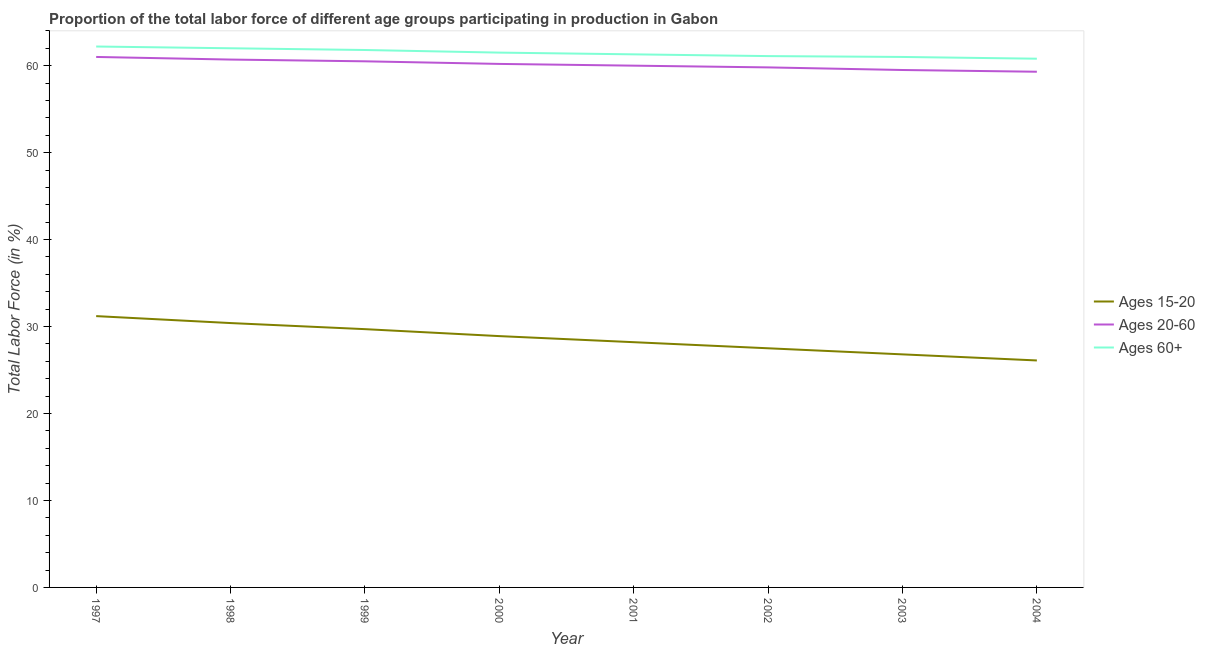Does the line corresponding to percentage of labor force within the age group 20-60 intersect with the line corresponding to percentage of labor force within the age group 15-20?
Make the answer very short. No. What is the percentage of labor force above age 60 in 1998?
Offer a very short reply. 62. Across all years, what is the minimum percentage of labor force within the age group 15-20?
Offer a very short reply. 26.1. In which year was the percentage of labor force within the age group 15-20 maximum?
Your answer should be compact. 1997. What is the total percentage of labor force within the age group 15-20 in the graph?
Your answer should be compact. 228.8. What is the difference between the percentage of labor force within the age group 15-20 in 1997 and that in 2001?
Keep it short and to the point. 3. What is the difference between the percentage of labor force within the age group 20-60 in 2001 and the percentage of labor force above age 60 in 2000?
Offer a terse response. -1.5. What is the average percentage of labor force within the age group 15-20 per year?
Make the answer very short. 28.6. In the year 2000, what is the difference between the percentage of labor force above age 60 and percentage of labor force within the age group 15-20?
Keep it short and to the point. 32.6. In how many years, is the percentage of labor force within the age group 15-20 greater than 4 %?
Keep it short and to the point. 8. What is the ratio of the percentage of labor force within the age group 20-60 in 2002 to that in 2003?
Your response must be concise. 1.01. Is the percentage of labor force within the age group 15-20 in 2000 less than that in 2003?
Offer a terse response. No. Is the difference between the percentage of labor force above age 60 in 1997 and 1999 greater than the difference between the percentage of labor force within the age group 20-60 in 1997 and 1999?
Offer a terse response. No. What is the difference between the highest and the second highest percentage of labor force within the age group 15-20?
Make the answer very short. 0.8. What is the difference between the highest and the lowest percentage of labor force above age 60?
Offer a terse response. 1.4. Is the sum of the percentage of labor force within the age group 20-60 in 2000 and 2002 greater than the maximum percentage of labor force within the age group 15-20 across all years?
Give a very brief answer. Yes. Is the percentage of labor force within the age group 15-20 strictly greater than the percentage of labor force above age 60 over the years?
Provide a succinct answer. No. Is the percentage of labor force above age 60 strictly less than the percentage of labor force within the age group 15-20 over the years?
Keep it short and to the point. No. Where does the legend appear in the graph?
Your response must be concise. Center right. How many legend labels are there?
Offer a very short reply. 3. What is the title of the graph?
Provide a short and direct response. Proportion of the total labor force of different age groups participating in production in Gabon. What is the Total Labor Force (in %) of Ages 15-20 in 1997?
Give a very brief answer. 31.2. What is the Total Labor Force (in %) in Ages 60+ in 1997?
Give a very brief answer. 62.2. What is the Total Labor Force (in %) of Ages 15-20 in 1998?
Your answer should be very brief. 30.4. What is the Total Labor Force (in %) in Ages 20-60 in 1998?
Offer a very short reply. 60.7. What is the Total Labor Force (in %) in Ages 60+ in 1998?
Make the answer very short. 62. What is the Total Labor Force (in %) in Ages 15-20 in 1999?
Ensure brevity in your answer.  29.7. What is the Total Labor Force (in %) in Ages 20-60 in 1999?
Your answer should be compact. 60.5. What is the Total Labor Force (in %) in Ages 60+ in 1999?
Provide a short and direct response. 61.8. What is the Total Labor Force (in %) in Ages 15-20 in 2000?
Provide a succinct answer. 28.9. What is the Total Labor Force (in %) in Ages 20-60 in 2000?
Make the answer very short. 60.2. What is the Total Labor Force (in %) of Ages 60+ in 2000?
Your answer should be compact. 61.5. What is the Total Labor Force (in %) of Ages 15-20 in 2001?
Your response must be concise. 28.2. What is the Total Labor Force (in %) of Ages 20-60 in 2001?
Offer a terse response. 60. What is the Total Labor Force (in %) of Ages 60+ in 2001?
Make the answer very short. 61.3. What is the Total Labor Force (in %) in Ages 15-20 in 2002?
Ensure brevity in your answer.  27.5. What is the Total Labor Force (in %) in Ages 20-60 in 2002?
Your answer should be very brief. 59.8. What is the Total Labor Force (in %) of Ages 60+ in 2002?
Your response must be concise. 61.1. What is the Total Labor Force (in %) of Ages 15-20 in 2003?
Provide a succinct answer. 26.8. What is the Total Labor Force (in %) in Ages 20-60 in 2003?
Ensure brevity in your answer.  59.5. What is the Total Labor Force (in %) in Ages 60+ in 2003?
Your response must be concise. 61. What is the Total Labor Force (in %) of Ages 15-20 in 2004?
Provide a short and direct response. 26.1. What is the Total Labor Force (in %) in Ages 20-60 in 2004?
Make the answer very short. 59.3. What is the Total Labor Force (in %) of Ages 60+ in 2004?
Provide a short and direct response. 60.8. Across all years, what is the maximum Total Labor Force (in %) in Ages 15-20?
Give a very brief answer. 31.2. Across all years, what is the maximum Total Labor Force (in %) of Ages 20-60?
Keep it short and to the point. 61. Across all years, what is the maximum Total Labor Force (in %) in Ages 60+?
Your answer should be very brief. 62.2. Across all years, what is the minimum Total Labor Force (in %) of Ages 15-20?
Provide a short and direct response. 26.1. Across all years, what is the minimum Total Labor Force (in %) in Ages 20-60?
Give a very brief answer. 59.3. Across all years, what is the minimum Total Labor Force (in %) of Ages 60+?
Offer a very short reply. 60.8. What is the total Total Labor Force (in %) in Ages 15-20 in the graph?
Provide a short and direct response. 228.8. What is the total Total Labor Force (in %) of Ages 20-60 in the graph?
Make the answer very short. 481. What is the total Total Labor Force (in %) of Ages 60+ in the graph?
Offer a terse response. 491.7. What is the difference between the Total Labor Force (in %) of Ages 15-20 in 1997 and that in 1998?
Keep it short and to the point. 0.8. What is the difference between the Total Labor Force (in %) in Ages 20-60 in 1997 and that in 1999?
Provide a succinct answer. 0.5. What is the difference between the Total Labor Force (in %) in Ages 15-20 in 1997 and that in 2000?
Provide a succinct answer. 2.3. What is the difference between the Total Labor Force (in %) of Ages 15-20 in 1997 and that in 2001?
Your answer should be compact. 3. What is the difference between the Total Labor Force (in %) of Ages 60+ in 1997 and that in 2001?
Provide a short and direct response. 0.9. What is the difference between the Total Labor Force (in %) of Ages 15-20 in 1997 and that in 2002?
Make the answer very short. 3.7. What is the difference between the Total Labor Force (in %) of Ages 20-60 in 1997 and that in 2002?
Give a very brief answer. 1.2. What is the difference between the Total Labor Force (in %) of Ages 60+ in 1997 and that in 2002?
Make the answer very short. 1.1. What is the difference between the Total Labor Force (in %) in Ages 15-20 in 1997 and that in 2003?
Make the answer very short. 4.4. What is the difference between the Total Labor Force (in %) of Ages 20-60 in 1997 and that in 2003?
Make the answer very short. 1.5. What is the difference between the Total Labor Force (in %) in Ages 60+ in 1997 and that in 2003?
Provide a succinct answer. 1.2. What is the difference between the Total Labor Force (in %) in Ages 15-20 in 1997 and that in 2004?
Your answer should be compact. 5.1. What is the difference between the Total Labor Force (in %) in Ages 15-20 in 1998 and that in 1999?
Keep it short and to the point. 0.7. What is the difference between the Total Labor Force (in %) of Ages 20-60 in 1998 and that in 1999?
Your response must be concise. 0.2. What is the difference between the Total Labor Force (in %) in Ages 60+ in 1998 and that in 1999?
Your response must be concise. 0.2. What is the difference between the Total Labor Force (in %) of Ages 20-60 in 1998 and that in 2000?
Your answer should be very brief. 0.5. What is the difference between the Total Labor Force (in %) of Ages 60+ in 1998 and that in 2000?
Keep it short and to the point. 0.5. What is the difference between the Total Labor Force (in %) of Ages 20-60 in 1998 and that in 2001?
Your response must be concise. 0.7. What is the difference between the Total Labor Force (in %) of Ages 20-60 in 1998 and that in 2002?
Offer a very short reply. 0.9. What is the difference between the Total Labor Force (in %) in Ages 15-20 in 1998 and that in 2003?
Make the answer very short. 3.6. What is the difference between the Total Labor Force (in %) in Ages 20-60 in 1998 and that in 2003?
Ensure brevity in your answer.  1.2. What is the difference between the Total Labor Force (in %) in Ages 60+ in 1998 and that in 2003?
Ensure brevity in your answer.  1. What is the difference between the Total Labor Force (in %) of Ages 15-20 in 1998 and that in 2004?
Offer a very short reply. 4.3. What is the difference between the Total Labor Force (in %) of Ages 60+ in 1998 and that in 2004?
Your answer should be compact. 1.2. What is the difference between the Total Labor Force (in %) of Ages 15-20 in 1999 and that in 2000?
Provide a succinct answer. 0.8. What is the difference between the Total Labor Force (in %) in Ages 60+ in 1999 and that in 2000?
Make the answer very short. 0.3. What is the difference between the Total Labor Force (in %) of Ages 20-60 in 1999 and that in 2001?
Offer a very short reply. 0.5. What is the difference between the Total Labor Force (in %) in Ages 20-60 in 1999 and that in 2002?
Provide a short and direct response. 0.7. What is the difference between the Total Labor Force (in %) of Ages 20-60 in 1999 and that in 2003?
Make the answer very short. 1. What is the difference between the Total Labor Force (in %) in Ages 20-60 in 1999 and that in 2004?
Ensure brevity in your answer.  1.2. What is the difference between the Total Labor Force (in %) of Ages 60+ in 2000 and that in 2001?
Provide a short and direct response. 0.2. What is the difference between the Total Labor Force (in %) of Ages 15-20 in 2000 and that in 2002?
Offer a terse response. 1.4. What is the difference between the Total Labor Force (in %) of Ages 60+ in 2000 and that in 2002?
Your response must be concise. 0.4. What is the difference between the Total Labor Force (in %) of Ages 60+ in 2000 and that in 2003?
Ensure brevity in your answer.  0.5. What is the difference between the Total Labor Force (in %) in Ages 15-20 in 2000 and that in 2004?
Give a very brief answer. 2.8. What is the difference between the Total Labor Force (in %) in Ages 60+ in 2000 and that in 2004?
Give a very brief answer. 0.7. What is the difference between the Total Labor Force (in %) in Ages 60+ in 2001 and that in 2002?
Your answer should be very brief. 0.2. What is the difference between the Total Labor Force (in %) of Ages 15-20 in 2001 and that in 2003?
Make the answer very short. 1.4. What is the difference between the Total Labor Force (in %) of Ages 20-60 in 2001 and that in 2003?
Ensure brevity in your answer.  0.5. What is the difference between the Total Labor Force (in %) in Ages 20-60 in 2001 and that in 2004?
Your answer should be compact. 0.7. What is the difference between the Total Labor Force (in %) in Ages 15-20 in 2002 and that in 2003?
Offer a terse response. 0.7. What is the difference between the Total Labor Force (in %) in Ages 20-60 in 2002 and that in 2003?
Make the answer very short. 0.3. What is the difference between the Total Labor Force (in %) of Ages 15-20 in 2002 and that in 2004?
Ensure brevity in your answer.  1.4. What is the difference between the Total Labor Force (in %) of Ages 20-60 in 2002 and that in 2004?
Offer a terse response. 0.5. What is the difference between the Total Labor Force (in %) of Ages 15-20 in 2003 and that in 2004?
Provide a succinct answer. 0.7. What is the difference between the Total Labor Force (in %) in Ages 60+ in 2003 and that in 2004?
Keep it short and to the point. 0.2. What is the difference between the Total Labor Force (in %) in Ages 15-20 in 1997 and the Total Labor Force (in %) in Ages 20-60 in 1998?
Ensure brevity in your answer.  -29.5. What is the difference between the Total Labor Force (in %) of Ages 15-20 in 1997 and the Total Labor Force (in %) of Ages 60+ in 1998?
Provide a short and direct response. -30.8. What is the difference between the Total Labor Force (in %) in Ages 15-20 in 1997 and the Total Labor Force (in %) in Ages 20-60 in 1999?
Ensure brevity in your answer.  -29.3. What is the difference between the Total Labor Force (in %) of Ages 15-20 in 1997 and the Total Labor Force (in %) of Ages 60+ in 1999?
Provide a short and direct response. -30.6. What is the difference between the Total Labor Force (in %) of Ages 20-60 in 1997 and the Total Labor Force (in %) of Ages 60+ in 1999?
Offer a terse response. -0.8. What is the difference between the Total Labor Force (in %) of Ages 15-20 in 1997 and the Total Labor Force (in %) of Ages 20-60 in 2000?
Your answer should be compact. -29. What is the difference between the Total Labor Force (in %) of Ages 15-20 in 1997 and the Total Labor Force (in %) of Ages 60+ in 2000?
Offer a very short reply. -30.3. What is the difference between the Total Labor Force (in %) in Ages 20-60 in 1997 and the Total Labor Force (in %) in Ages 60+ in 2000?
Provide a short and direct response. -0.5. What is the difference between the Total Labor Force (in %) in Ages 15-20 in 1997 and the Total Labor Force (in %) in Ages 20-60 in 2001?
Your answer should be very brief. -28.8. What is the difference between the Total Labor Force (in %) of Ages 15-20 in 1997 and the Total Labor Force (in %) of Ages 60+ in 2001?
Offer a terse response. -30.1. What is the difference between the Total Labor Force (in %) of Ages 15-20 in 1997 and the Total Labor Force (in %) of Ages 20-60 in 2002?
Your answer should be compact. -28.6. What is the difference between the Total Labor Force (in %) in Ages 15-20 in 1997 and the Total Labor Force (in %) in Ages 60+ in 2002?
Your response must be concise. -29.9. What is the difference between the Total Labor Force (in %) of Ages 20-60 in 1997 and the Total Labor Force (in %) of Ages 60+ in 2002?
Provide a short and direct response. -0.1. What is the difference between the Total Labor Force (in %) in Ages 15-20 in 1997 and the Total Labor Force (in %) in Ages 20-60 in 2003?
Provide a short and direct response. -28.3. What is the difference between the Total Labor Force (in %) in Ages 15-20 in 1997 and the Total Labor Force (in %) in Ages 60+ in 2003?
Your answer should be compact. -29.8. What is the difference between the Total Labor Force (in %) of Ages 20-60 in 1997 and the Total Labor Force (in %) of Ages 60+ in 2003?
Provide a succinct answer. 0. What is the difference between the Total Labor Force (in %) of Ages 15-20 in 1997 and the Total Labor Force (in %) of Ages 20-60 in 2004?
Keep it short and to the point. -28.1. What is the difference between the Total Labor Force (in %) of Ages 15-20 in 1997 and the Total Labor Force (in %) of Ages 60+ in 2004?
Ensure brevity in your answer.  -29.6. What is the difference between the Total Labor Force (in %) of Ages 20-60 in 1997 and the Total Labor Force (in %) of Ages 60+ in 2004?
Offer a very short reply. 0.2. What is the difference between the Total Labor Force (in %) of Ages 15-20 in 1998 and the Total Labor Force (in %) of Ages 20-60 in 1999?
Your answer should be compact. -30.1. What is the difference between the Total Labor Force (in %) in Ages 15-20 in 1998 and the Total Labor Force (in %) in Ages 60+ in 1999?
Keep it short and to the point. -31.4. What is the difference between the Total Labor Force (in %) in Ages 15-20 in 1998 and the Total Labor Force (in %) in Ages 20-60 in 2000?
Provide a short and direct response. -29.8. What is the difference between the Total Labor Force (in %) of Ages 15-20 in 1998 and the Total Labor Force (in %) of Ages 60+ in 2000?
Make the answer very short. -31.1. What is the difference between the Total Labor Force (in %) in Ages 15-20 in 1998 and the Total Labor Force (in %) in Ages 20-60 in 2001?
Your answer should be very brief. -29.6. What is the difference between the Total Labor Force (in %) of Ages 15-20 in 1998 and the Total Labor Force (in %) of Ages 60+ in 2001?
Provide a short and direct response. -30.9. What is the difference between the Total Labor Force (in %) in Ages 20-60 in 1998 and the Total Labor Force (in %) in Ages 60+ in 2001?
Your answer should be compact. -0.6. What is the difference between the Total Labor Force (in %) of Ages 15-20 in 1998 and the Total Labor Force (in %) of Ages 20-60 in 2002?
Keep it short and to the point. -29.4. What is the difference between the Total Labor Force (in %) of Ages 15-20 in 1998 and the Total Labor Force (in %) of Ages 60+ in 2002?
Make the answer very short. -30.7. What is the difference between the Total Labor Force (in %) in Ages 20-60 in 1998 and the Total Labor Force (in %) in Ages 60+ in 2002?
Keep it short and to the point. -0.4. What is the difference between the Total Labor Force (in %) in Ages 15-20 in 1998 and the Total Labor Force (in %) in Ages 20-60 in 2003?
Your answer should be very brief. -29.1. What is the difference between the Total Labor Force (in %) of Ages 15-20 in 1998 and the Total Labor Force (in %) of Ages 60+ in 2003?
Give a very brief answer. -30.6. What is the difference between the Total Labor Force (in %) of Ages 20-60 in 1998 and the Total Labor Force (in %) of Ages 60+ in 2003?
Give a very brief answer. -0.3. What is the difference between the Total Labor Force (in %) in Ages 15-20 in 1998 and the Total Labor Force (in %) in Ages 20-60 in 2004?
Your response must be concise. -28.9. What is the difference between the Total Labor Force (in %) of Ages 15-20 in 1998 and the Total Labor Force (in %) of Ages 60+ in 2004?
Your answer should be compact. -30.4. What is the difference between the Total Labor Force (in %) in Ages 15-20 in 1999 and the Total Labor Force (in %) in Ages 20-60 in 2000?
Provide a succinct answer. -30.5. What is the difference between the Total Labor Force (in %) of Ages 15-20 in 1999 and the Total Labor Force (in %) of Ages 60+ in 2000?
Keep it short and to the point. -31.8. What is the difference between the Total Labor Force (in %) of Ages 20-60 in 1999 and the Total Labor Force (in %) of Ages 60+ in 2000?
Provide a succinct answer. -1. What is the difference between the Total Labor Force (in %) of Ages 15-20 in 1999 and the Total Labor Force (in %) of Ages 20-60 in 2001?
Keep it short and to the point. -30.3. What is the difference between the Total Labor Force (in %) of Ages 15-20 in 1999 and the Total Labor Force (in %) of Ages 60+ in 2001?
Your response must be concise. -31.6. What is the difference between the Total Labor Force (in %) of Ages 15-20 in 1999 and the Total Labor Force (in %) of Ages 20-60 in 2002?
Provide a succinct answer. -30.1. What is the difference between the Total Labor Force (in %) of Ages 15-20 in 1999 and the Total Labor Force (in %) of Ages 60+ in 2002?
Your response must be concise. -31.4. What is the difference between the Total Labor Force (in %) in Ages 20-60 in 1999 and the Total Labor Force (in %) in Ages 60+ in 2002?
Your answer should be compact. -0.6. What is the difference between the Total Labor Force (in %) in Ages 15-20 in 1999 and the Total Labor Force (in %) in Ages 20-60 in 2003?
Your answer should be compact. -29.8. What is the difference between the Total Labor Force (in %) of Ages 15-20 in 1999 and the Total Labor Force (in %) of Ages 60+ in 2003?
Provide a short and direct response. -31.3. What is the difference between the Total Labor Force (in %) in Ages 15-20 in 1999 and the Total Labor Force (in %) in Ages 20-60 in 2004?
Keep it short and to the point. -29.6. What is the difference between the Total Labor Force (in %) in Ages 15-20 in 1999 and the Total Labor Force (in %) in Ages 60+ in 2004?
Make the answer very short. -31.1. What is the difference between the Total Labor Force (in %) in Ages 20-60 in 1999 and the Total Labor Force (in %) in Ages 60+ in 2004?
Offer a terse response. -0.3. What is the difference between the Total Labor Force (in %) in Ages 15-20 in 2000 and the Total Labor Force (in %) in Ages 20-60 in 2001?
Offer a terse response. -31.1. What is the difference between the Total Labor Force (in %) of Ages 15-20 in 2000 and the Total Labor Force (in %) of Ages 60+ in 2001?
Provide a short and direct response. -32.4. What is the difference between the Total Labor Force (in %) of Ages 15-20 in 2000 and the Total Labor Force (in %) of Ages 20-60 in 2002?
Your answer should be compact. -30.9. What is the difference between the Total Labor Force (in %) in Ages 15-20 in 2000 and the Total Labor Force (in %) in Ages 60+ in 2002?
Your response must be concise. -32.2. What is the difference between the Total Labor Force (in %) in Ages 15-20 in 2000 and the Total Labor Force (in %) in Ages 20-60 in 2003?
Give a very brief answer. -30.6. What is the difference between the Total Labor Force (in %) in Ages 15-20 in 2000 and the Total Labor Force (in %) in Ages 60+ in 2003?
Give a very brief answer. -32.1. What is the difference between the Total Labor Force (in %) in Ages 15-20 in 2000 and the Total Labor Force (in %) in Ages 20-60 in 2004?
Your answer should be compact. -30.4. What is the difference between the Total Labor Force (in %) of Ages 15-20 in 2000 and the Total Labor Force (in %) of Ages 60+ in 2004?
Your answer should be very brief. -31.9. What is the difference between the Total Labor Force (in %) of Ages 20-60 in 2000 and the Total Labor Force (in %) of Ages 60+ in 2004?
Give a very brief answer. -0.6. What is the difference between the Total Labor Force (in %) in Ages 15-20 in 2001 and the Total Labor Force (in %) in Ages 20-60 in 2002?
Keep it short and to the point. -31.6. What is the difference between the Total Labor Force (in %) of Ages 15-20 in 2001 and the Total Labor Force (in %) of Ages 60+ in 2002?
Provide a succinct answer. -32.9. What is the difference between the Total Labor Force (in %) in Ages 20-60 in 2001 and the Total Labor Force (in %) in Ages 60+ in 2002?
Make the answer very short. -1.1. What is the difference between the Total Labor Force (in %) of Ages 15-20 in 2001 and the Total Labor Force (in %) of Ages 20-60 in 2003?
Keep it short and to the point. -31.3. What is the difference between the Total Labor Force (in %) of Ages 15-20 in 2001 and the Total Labor Force (in %) of Ages 60+ in 2003?
Your answer should be compact. -32.8. What is the difference between the Total Labor Force (in %) of Ages 15-20 in 2001 and the Total Labor Force (in %) of Ages 20-60 in 2004?
Your answer should be compact. -31.1. What is the difference between the Total Labor Force (in %) in Ages 15-20 in 2001 and the Total Labor Force (in %) in Ages 60+ in 2004?
Ensure brevity in your answer.  -32.6. What is the difference between the Total Labor Force (in %) of Ages 15-20 in 2002 and the Total Labor Force (in %) of Ages 20-60 in 2003?
Provide a succinct answer. -32. What is the difference between the Total Labor Force (in %) in Ages 15-20 in 2002 and the Total Labor Force (in %) in Ages 60+ in 2003?
Give a very brief answer. -33.5. What is the difference between the Total Labor Force (in %) in Ages 15-20 in 2002 and the Total Labor Force (in %) in Ages 20-60 in 2004?
Keep it short and to the point. -31.8. What is the difference between the Total Labor Force (in %) in Ages 15-20 in 2002 and the Total Labor Force (in %) in Ages 60+ in 2004?
Offer a terse response. -33.3. What is the difference between the Total Labor Force (in %) in Ages 20-60 in 2002 and the Total Labor Force (in %) in Ages 60+ in 2004?
Your answer should be compact. -1. What is the difference between the Total Labor Force (in %) in Ages 15-20 in 2003 and the Total Labor Force (in %) in Ages 20-60 in 2004?
Your answer should be very brief. -32.5. What is the difference between the Total Labor Force (in %) in Ages 15-20 in 2003 and the Total Labor Force (in %) in Ages 60+ in 2004?
Provide a succinct answer. -34. What is the difference between the Total Labor Force (in %) of Ages 20-60 in 2003 and the Total Labor Force (in %) of Ages 60+ in 2004?
Your answer should be compact. -1.3. What is the average Total Labor Force (in %) in Ages 15-20 per year?
Offer a very short reply. 28.6. What is the average Total Labor Force (in %) in Ages 20-60 per year?
Your answer should be very brief. 60.12. What is the average Total Labor Force (in %) of Ages 60+ per year?
Your answer should be compact. 61.46. In the year 1997, what is the difference between the Total Labor Force (in %) of Ages 15-20 and Total Labor Force (in %) of Ages 20-60?
Provide a succinct answer. -29.8. In the year 1997, what is the difference between the Total Labor Force (in %) of Ages 15-20 and Total Labor Force (in %) of Ages 60+?
Provide a short and direct response. -31. In the year 1998, what is the difference between the Total Labor Force (in %) of Ages 15-20 and Total Labor Force (in %) of Ages 20-60?
Offer a very short reply. -30.3. In the year 1998, what is the difference between the Total Labor Force (in %) of Ages 15-20 and Total Labor Force (in %) of Ages 60+?
Provide a succinct answer. -31.6. In the year 1998, what is the difference between the Total Labor Force (in %) in Ages 20-60 and Total Labor Force (in %) in Ages 60+?
Your answer should be very brief. -1.3. In the year 1999, what is the difference between the Total Labor Force (in %) of Ages 15-20 and Total Labor Force (in %) of Ages 20-60?
Keep it short and to the point. -30.8. In the year 1999, what is the difference between the Total Labor Force (in %) of Ages 15-20 and Total Labor Force (in %) of Ages 60+?
Keep it short and to the point. -32.1. In the year 2000, what is the difference between the Total Labor Force (in %) of Ages 15-20 and Total Labor Force (in %) of Ages 20-60?
Give a very brief answer. -31.3. In the year 2000, what is the difference between the Total Labor Force (in %) in Ages 15-20 and Total Labor Force (in %) in Ages 60+?
Your answer should be compact. -32.6. In the year 2000, what is the difference between the Total Labor Force (in %) in Ages 20-60 and Total Labor Force (in %) in Ages 60+?
Give a very brief answer. -1.3. In the year 2001, what is the difference between the Total Labor Force (in %) of Ages 15-20 and Total Labor Force (in %) of Ages 20-60?
Provide a succinct answer. -31.8. In the year 2001, what is the difference between the Total Labor Force (in %) in Ages 15-20 and Total Labor Force (in %) in Ages 60+?
Provide a succinct answer. -33.1. In the year 2001, what is the difference between the Total Labor Force (in %) in Ages 20-60 and Total Labor Force (in %) in Ages 60+?
Provide a short and direct response. -1.3. In the year 2002, what is the difference between the Total Labor Force (in %) in Ages 15-20 and Total Labor Force (in %) in Ages 20-60?
Your response must be concise. -32.3. In the year 2002, what is the difference between the Total Labor Force (in %) in Ages 15-20 and Total Labor Force (in %) in Ages 60+?
Your response must be concise. -33.6. In the year 2002, what is the difference between the Total Labor Force (in %) of Ages 20-60 and Total Labor Force (in %) of Ages 60+?
Keep it short and to the point. -1.3. In the year 2003, what is the difference between the Total Labor Force (in %) of Ages 15-20 and Total Labor Force (in %) of Ages 20-60?
Offer a terse response. -32.7. In the year 2003, what is the difference between the Total Labor Force (in %) of Ages 15-20 and Total Labor Force (in %) of Ages 60+?
Ensure brevity in your answer.  -34.2. In the year 2004, what is the difference between the Total Labor Force (in %) in Ages 15-20 and Total Labor Force (in %) in Ages 20-60?
Give a very brief answer. -33.2. In the year 2004, what is the difference between the Total Labor Force (in %) in Ages 15-20 and Total Labor Force (in %) in Ages 60+?
Your answer should be very brief. -34.7. In the year 2004, what is the difference between the Total Labor Force (in %) in Ages 20-60 and Total Labor Force (in %) in Ages 60+?
Offer a terse response. -1.5. What is the ratio of the Total Labor Force (in %) in Ages 15-20 in 1997 to that in 1998?
Offer a very short reply. 1.03. What is the ratio of the Total Labor Force (in %) of Ages 20-60 in 1997 to that in 1998?
Ensure brevity in your answer.  1. What is the ratio of the Total Labor Force (in %) in Ages 15-20 in 1997 to that in 1999?
Make the answer very short. 1.05. What is the ratio of the Total Labor Force (in %) of Ages 20-60 in 1997 to that in 1999?
Provide a short and direct response. 1.01. What is the ratio of the Total Labor Force (in %) in Ages 15-20 in 1997 to that in 2000?
Provide a short and direct response. 1.08. What is the ratio of the Total Labor Force (in %) in Ages 20-60 in 1997 to that in 2000?
Provide a succinct answer. 1.01. What is the ratio of the Total Labor Force (in %) in Ages 60+ in 1997 to that in 2000?
Your answer should be compact. 1.01. What is the ratio of the Total Labor Force (in %) of Ages 15-20 in 1997 to that in 2001?
Your response must be concise. 1.11. What is the ratio of the Total Labor Force (in %) in Ages 20-60 in 1997 to that in 2001?
Your response must be concise. 1.02. What is the ratio of the Total Labor Force (in %) in Ages 60+ in 1997 to that in 2001?
Your answer should be very brief. 1.01. What is the ratio of the Total Labor Force (in %) of Ages 15-20 in 1997 to that in 2002?
Your response must be concise. 1.13. What is the ratio of the Total Labor Force (in %) in Ages 20-60 in 1997 to that in 2002?
Your answer should be very brief. 1.02. What is the ratio of the Total Labor Force (in %) of Ages 15-20 in 1997 to that in 2003?
Offer a very short reply. 1.16. What is the ratio of the Total Labor Force (in %) of Ages 20-60 in 1997 to that in 2003?
Your answer should be very brief. 1.03. What is the ratio of the Total Labor Force (in %) of Ages 60+ in 1997 to that in 2003?
Offer a very short reply. 1.02. What is the ratio of the Total Labor Force (in %) of Ages 15-20 in 1997 to that in 2004?
Your response must be concise. 1.2. What is the ratio of the Total Labor Force (in %) in Ages 20-60 in 1997 to that in 2004?
Keep it short and to the point. 1.03. What is the ratio of the Total Labor Force (in %) in Ages 15-20 in 1998 to that in 1999?
Ensure brevity in your answer.  1.02. What is the ratio of the Total Labor Force (in %) in Ages 20-60 in 1998 to that in 1999?
Your response must be concise. 1. What is the ratio of the Total Labor Force (in %) in Ages 60+ in 1998 to that in 1999?
Make the answer very short. 1. What is the ratio of the Total Labor Force (in %) of Ages 15-20 in 1998 to that in 2000?
Offer a terse response. 1.05. What is the ratio of the Total Labor Force (in %) of Ages 20-60 in 1998 to that in 2000?
Provide a short and direct response. 1.01. What is the ratio of the Total Labor Force (in %) of Ages 15-20 in 1998 to that in 2001?
Provide a short and direct response. 1.08. What is the ratio of the Total Labor Force (in %) in Ages 20-60 in 1998 to that in 2001?
Offer a very short reply. 1.01. What is the ratio of the Total Labor Force (in %) of Ages 60+ in 1998 to that in 2001?
Provide a succinct answer. 1.01. What is the ratio of the Total Labor Force (in %) of Ages 15-20 in 1998 to that in 2002?
Provide a succinct answer. 1.11. What is the ratio of the Total Labor Force (in %) of Ages 20-60 in 1998 to that in 2002?
Provide a short and direct response. 1.02. What is the ratio of the Total Labor Force (in %) in Ages 60+ in 1998 to that in 2002?
Your answer should be very brief. 1.01. What is the ratio of the Total Labor Force (in %) in Ages 15-20 in 1998 to that in 2003?
Your answer should be compact. 1.13. What is the ratio of the Total Labor Force (in %) of Ages 20-60 in 1998 to that in 2003?
Keep it short and to the point. 1.02. What is the ratio of the Total Labor Force (in %) of Ages 60+ in 1998 to that in 2003?
Offer a very short reply. 1.02. What is the ratio of the Total Labor Force (in %) in Ages 15-20 in 1998 to that in 2004?
Your response must be concise. 1.16. What is the ratio of the Total Labor Force (in %) of Ages 20-60 in 1998 to that in 2004?
Provide a succinct answer. 1.02. What is the ratio of the Total Labor Force (in %) in Ages 60+ in 1998 to that in 2004?
Provide a succinct answer. 1.02. What is the ratio of the Total Labor Force (in %) of Ages 15-20 in 1999 to that in 2000?
Your response must be concise. 1.03. What is the ratio of the Total Labor Force (in %) in Ages 60+ in 1999 to that in 2000?
Keep it short and to the point. 1. What is the ratio of the Total Labor Force (in %) of Ages 15-20 in 1999 to that in 2001?
Give a very brief answer. 1.05. What is the ratio of the Total Labor Force (in %) in Ages 20-60 in 1999 to that in 2001?
Ensure brevity in your answer.  1.01. What is the ratio of the Total Labor Force (in %) of Ages 60+ in 1999 to that in 2001?
Give a very brief answer. 1.01. What is the ratio of the Total Labor Force (in %) of Ages 15-20 in 1999 to that in 2002?
Make the answer very short. 1.08. What is the ratio of the Total Labor Force (in %) in Ages 20-60 in 1999 to that in 2002?
Keep it short and to the point. 1.01. What is the ratio of the Total Labor Force (in %) in Ages 60+ in 1999 to that in 2002?
Ensure brevity in your answer.  1.01. What is the ratio of the Total Labor Force (in %) of Ages 15-20 in 1999 to that in 2003?
Provide a succinct answer. 1.11. What is the ratio of the Total Labor Force (in %) of Ages 20-60 in 1999 to that in 2003?
Your answer should be very brief. 1.02. What is the ratio of the Total Labor Force (in %) of Ages 60+ in 1999 to that in 2003?
Keep it short and to the point. 1.01. What is the ratio of the Total Labor Force (in %) of Ages 15-20 in 1999 to that in 2004?
Your response must be concise. 1.14. What is the ratio of the Total Labor Force (in %) in Ages 20-60 in 1999 to that in 2004?
Ensure brevity in your answer.  1.02. What is the ratio of the Total Labor Force (in %) in Ages 60+ in 1999 to that in 2004?
Offer a very short reply. 1.02. What is the ratio of the Total Labor Force (in %) of Ages 15-20 in 2000 to that in 2001?
Your answer should be compact. 1.02. What is the ratio of the Total Labor Force (in %) of Ages 20-60 in 2000 to that in 2001?
Offer a very short reply. 1. What is the ratio of the Total Labor Force (in %) of Ages 15-20 in 2000 to that in 2002?
Offer a very short reply. 1.05. What is the ratio of the Total Labor Force (in %) in Ages 20-60 in 2000 to that in 2002?
Keep it short and to the point. 1.01. What is the ratio of the Total Labor Force (in %) in Ages 60+ in 2000 to that in 2002?
Ensure brevity in your answer.  1.01. What is the ratio of the Total Labor Force (in %) of Ages 15-20 in 2000 to that in 2003?
Provide a short and direct response. 1.08. What is the ratio of the Total Labor Force (in %) of Ages 20-60 in 2000 to that in 2003?
Offer a very short reply. 1.01. What is the ratio of the Total Labor Force (in %) in Ages 60+ in 2000 to that in 2003?
Keep it short and to the point. 1.01. What is the ratio of the Total Labor Force (in %) in Ages 15-20 in 2000 to that in 2004?
Provide a short and direct response. 1.11. What is the ratio of the Total Labor Force (in %) of Ages 20-60 in 2000 to that in 2004?
Offer a very short reply. 1.02. What is the ratio of the Total Labor Force (in %) in Ages 60+ in 2000 to that in 2004?
Give a very brief answer. 1.01. What is the ratio of the Total Labor Force (in %) of Ages 15-20 in 2001 to that in 2002?
Offer a very short reply. 1.03. What is the ratio of the Total Labor Force (in %) in Ages 15-20 in 2001 to that in 2003?
Provide a short and direct response. 1.05. What is the ratio of the Total Labor Force (in %) in Ages 20-60 in 2001 to that in 2003?
Ensure brevity in your answer.  1.01. What is the ratio of the Total Labor Force (in %) of Ages 60+ in 2001 to that in 2003?
Your answer should be compact. 1. What is the ratio of the Total Labor Force (in %) of Ages 15-20 in 2001 to that in 2004?
Your answer should be very brief. 1.08. What is the ratio of the Total Labor Force (in %) in Ages 20-60 in 2001 to that in 2004?
Your answer should be compact. 1.01. What is the ratio of the Total Labor Force (in %) of Ages 60+ in 2001 to that in 2004?
Ensure brevity in your answer.  1.01. What is the ratio of the Total Labor Force (in %) in Ages 15-20 in 2002 to that in 2003?
Ensure brevity in your answer.  1.03. What is the ratio of the Total Labor Force (in %) of Ages 15-20 in 2002 to that in 2004?
Ensure brevity in your answer.  1.05. What is the ratio of the Total Labor Force (in %) in Ages 20-60 in 2002 to that in 2004?
Give a very brief answer. 1.01. What is the ratio of the Total Labor Force (in %) of Ages 15-20 in 2003 to that in 2004?
Your response must be concise. 1.03. What is the difference between the highest and the second highest Total Labor Force (in %) of Ages 15-20?
Make the answer very short. 0.8. What is the difference between the highest and the second highest Total Labor Force (in %) in Ages 20-60?
Your answer should be compact. 0.3. 